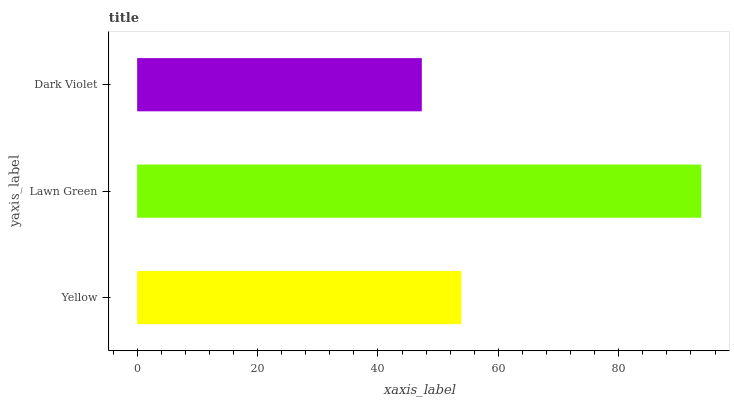Is Dark Violet the minimum?
Answer yes or no. Yes. Is Lawn Green the maximum?
Answer yes or no. Yes. Is Lawn Green the minimum?
Answer yes or no. No. Is Dark Violet the maximum?
Answer yes or no. No. Is Lawn Green greater than Dark Violet?
Answer yes or no. Yes. Is Dark Violet less than Lawn Green?
Answer yes or no. Yes. Is Dark Violet greater than Lawn Green?
Answer yes or no. No. Is Lawn Green less than Dark Violet?
Answer yes or no. No. Is Yellow the high median?
Answer yes or no. Yes. Is Yellow the low median?
Answer yes or no. Yes. Is Lawn Green the high median?
Answer yes or no. No. Is Dark Violet the low median?
Answer yes or no. No. 